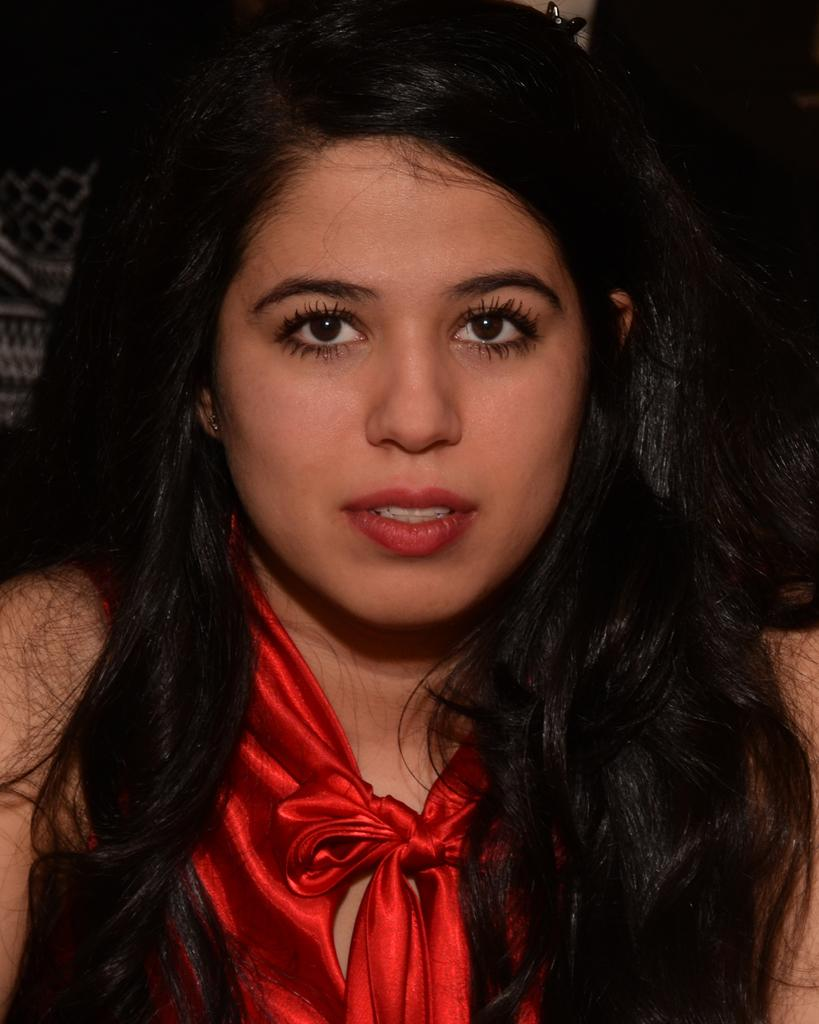Who is present in the image? There is a woman in the image. What is the woman wearing? The woman is wearing a red dress. Where is the woman located in the image? The woman is sitting near a wall. What type of bell can be heard ringing in the image? There is no bell present or ringing in the image. What topic is the woman discussing with someone in the image? The image does not show any discussion or interaction between the woman and another person. 